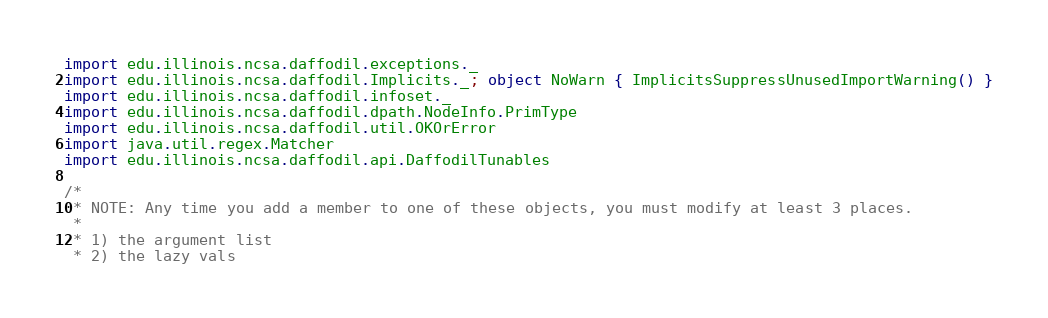Convert code to text. <code><loc_0><loc_0><loc_500><loc_500><_Scala_>import edu.illinois.ncsa.daffodil.exceptions._
import edu.illinois.ncsa.daffodil.Implicits._; object NoWarn { ImplicitsSuppressUnusedImportWarning() }
import edu.illinois.ncsa.daffodil.infoset._
import edu.illinois.ncsa.daffodil.dpath.NodeInfo.PrimType
import edu.illinois.ncsa.daffodil.util.OKOrError
import java.util.regex.Matcher
import edu.illinois.ncsa.daffodil.api.DaffodilTunables

/*
 * NOTE: Any time you add a member to one of these objects, you must modify at least 3 places.
 *
 * 1) the argument list
 * 2) the lazy vals</code> 